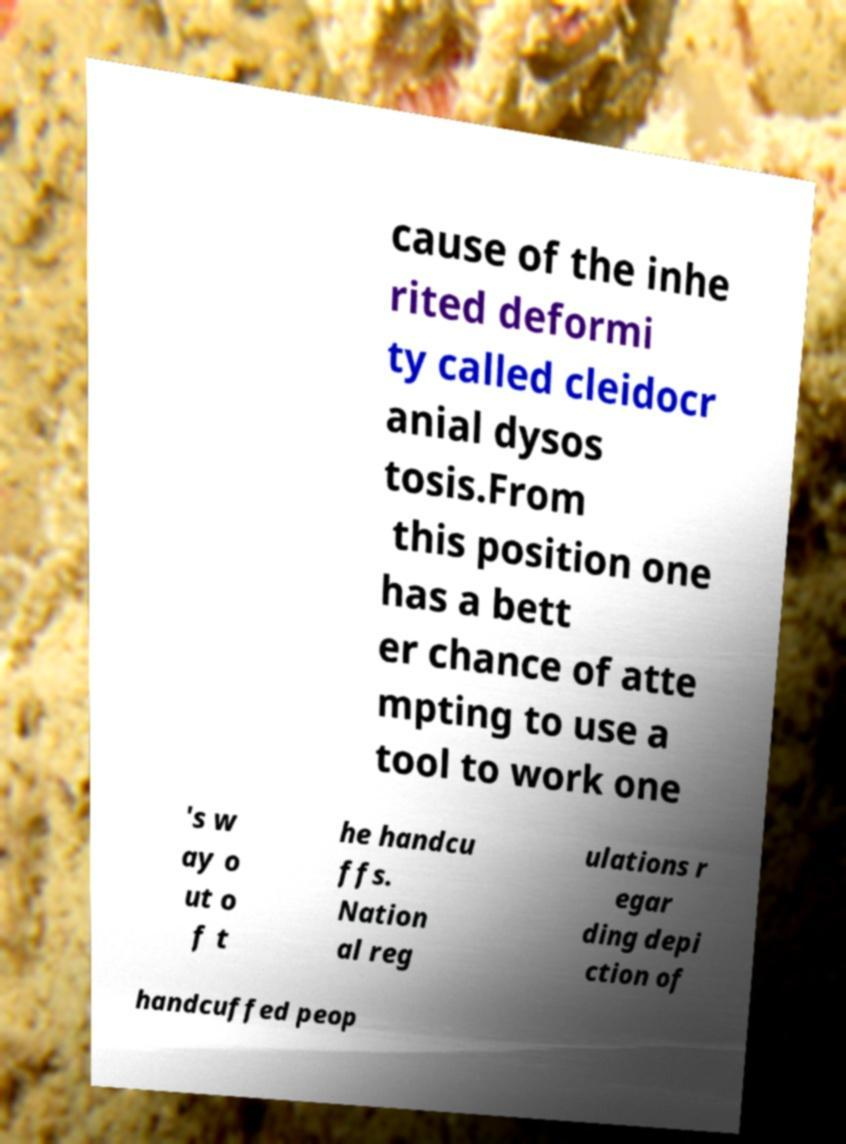Please identify and transcribe the text found in this image. cause of the inhe rited deformi ty called cleidocr anial dysos tosis.From this position one has a bett er chance of atte mpting to use a tool to work one 's w ay o ut o f t he handcu ffs. Nation al reg ulations r egar ding depi ction of handcuffed peop 